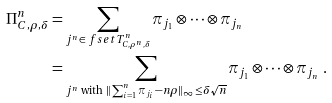Convert formula to latex. <formula><loc_0><loc_0><loc_500><loc_500>\Pi ^ { n } _ { C , \rho , \delta } & = \sum _ { j ^ { n } \in \ f s e t { T } ^ { n } _ { C , \rho ^ { n } , \delta } } \pi _ { j _ { 1 } } \otimes \cdots \otimes \pi _ { j _ { n } } \\ & = \sum _ { j ^ { n } \text { with } \| \sum _ { i = 1 } ^ { n } \pi _ { j _ { i } } - n \rho \| _ { \infty } \leq \delta \sqrt { n } } \pi _ { j _ { 1 } } \otimes \cdots \otimes \pi _ { j _ { n } } \ .</formula> 